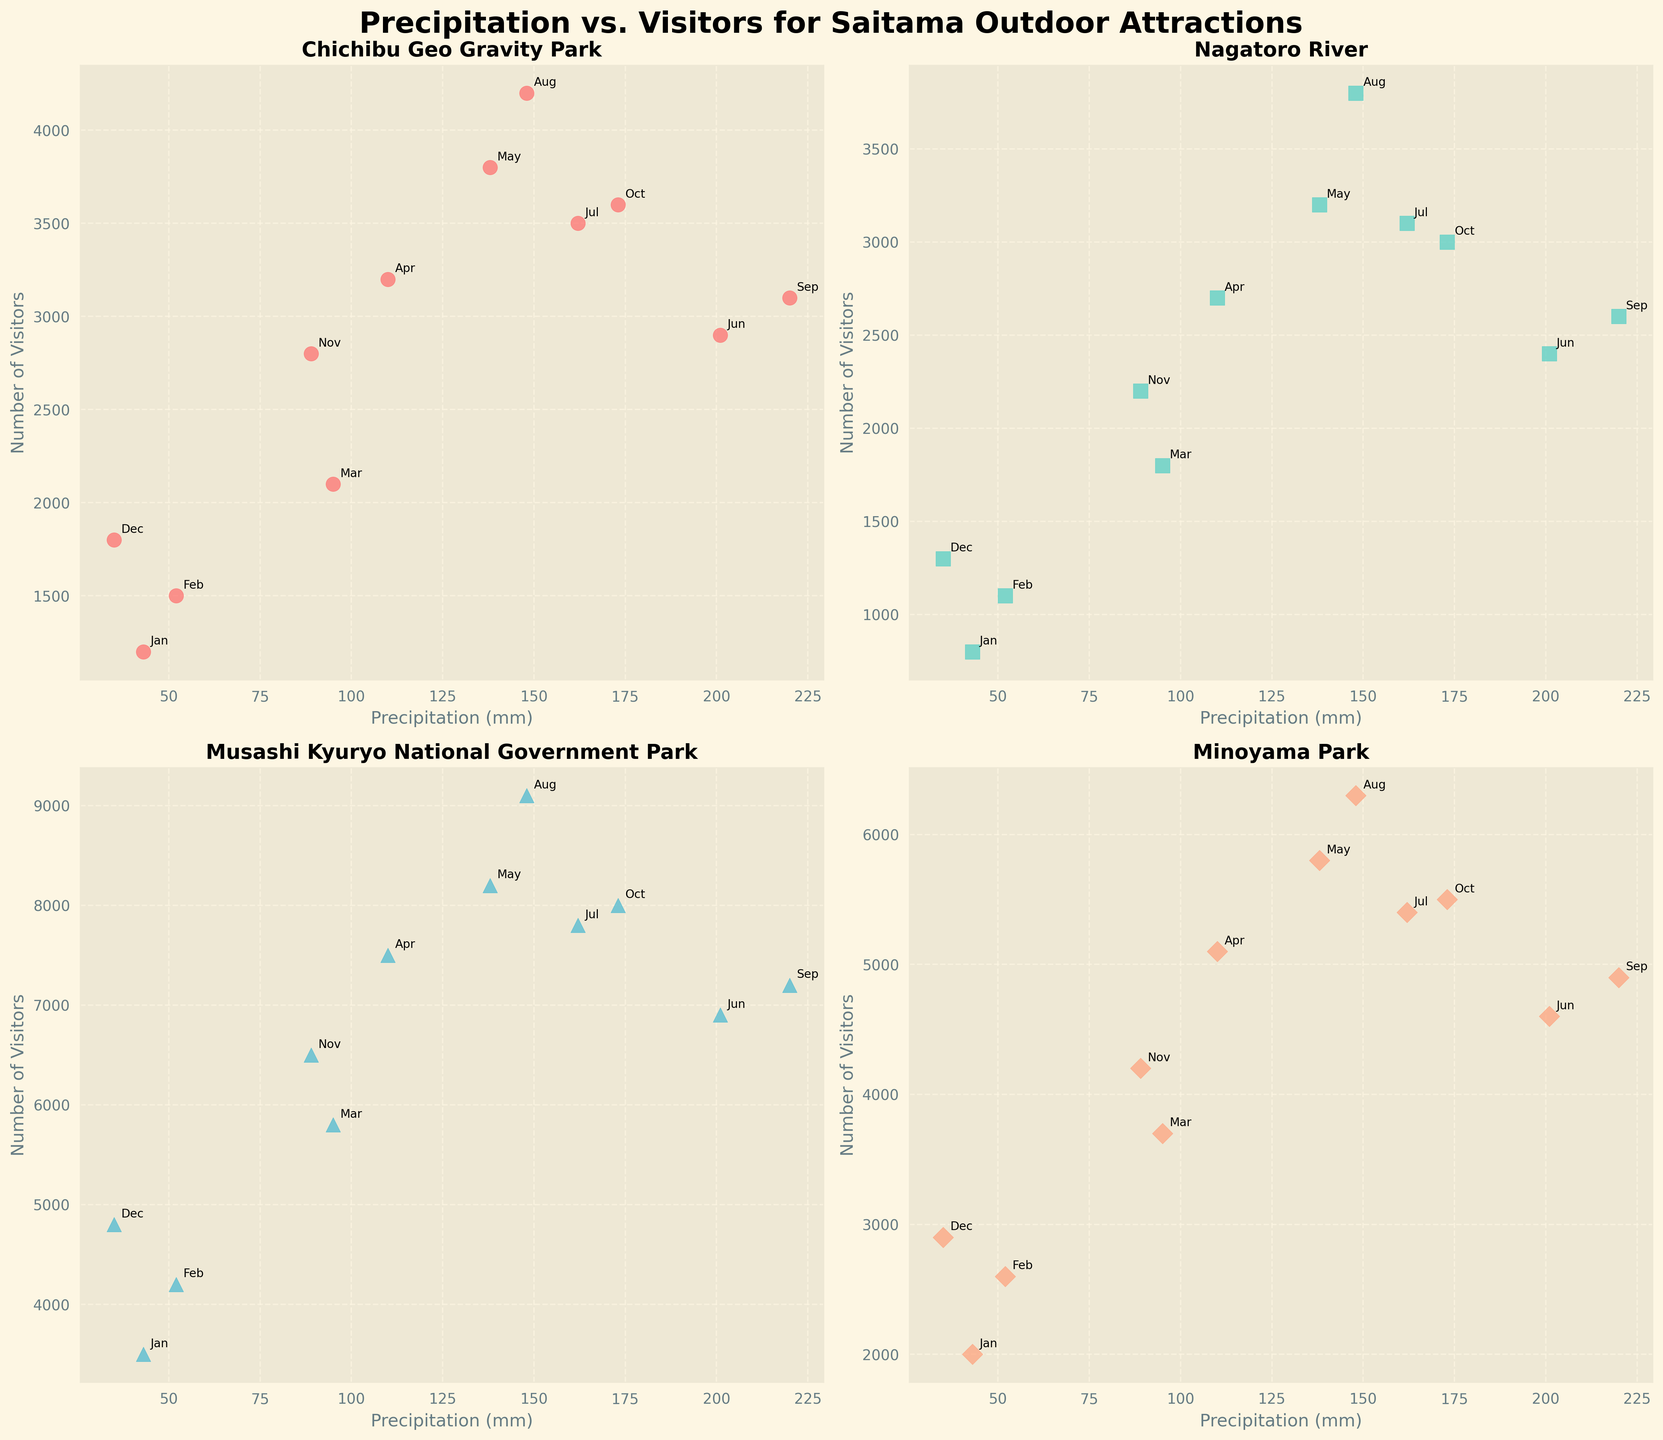What's the trend of visitor numbers with increasing precipitation for Chichibu Geo Gravity Park? By examining the scatter plot for Chichibu Geo Gravity Park, it shows that while there is some fluctuation, generally, the number of visitors declines as precipitation levels increase, especially during peak rainfall months like June (201 mm) and September (220 mm).
Answer: The number of visitors generally declines Between Musashi Kyuryo National Government Park and Minoyama Park, which attraction receives the most visitors during months with less than 100 mm of precipitation? Looking at the scatter plots, for months with less than 100 mm of precipitation (Jan, Feb, Mar, Nov, and Dec), Musashi Kyuryo National Government Park has significantly more visitors compared to Minoyama Park. For example, in January, Musashi Kyuryo has 3500 visitors compared to Minoyama Park's 2000.
Answer: Musashi Kyuryo National Government Park Which attraction shows the steepest decline in visitors as precipitation levels rise from May to September? By comparing the plots, Minoyama Park shows a steep decline in visitors from May (5800 visitors with 138 mm) to September (4900 visitors with 220 mm).
Answer: Minoyama Park For Nagatoro River, what is the average number of visitors during months with precipitation between 100 mm and 200 mm? The months of April, May, June, July, and August fall within this range with visitor numbers of 2700, 3200, 2400, 3100, and 3800 respectively. The average is calculated as (2700 + 3200 + 2400 + 3100 + 3800) / 5 = 15200 / 5
Answer: 3040 Which month has the highest number of visitors for Musashi Kyuryo National Government Park and what is the precipitation level for that month? In the scatter plot for Musashi Kyuryo National Government Park, August has the highest visitor count of 9100 and has a precipitation level of 148 mm.
Answer: August, 148 mm 